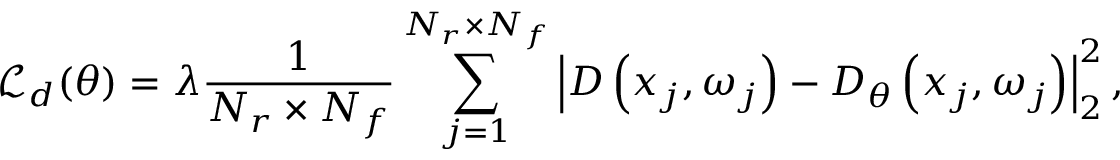Convert formula to latex. <formula><loc_0><loc_0><loc_500><loc_500>\mathcal { L } _ { d } ( \theta ) = \lambda \frac { 1 } { N _ { r } \times N _ { f } } \sum _ { j = 1 } ^ { N _ { r } \times N _ { f } } \left | D \left ( x _ { j } , \omega _ { j } \right ) - D _ { \theta } \left ( x _ { j } , \omega _ { j } \right ) \right | _ { 2 } ^ { 2 } ,</formula> 